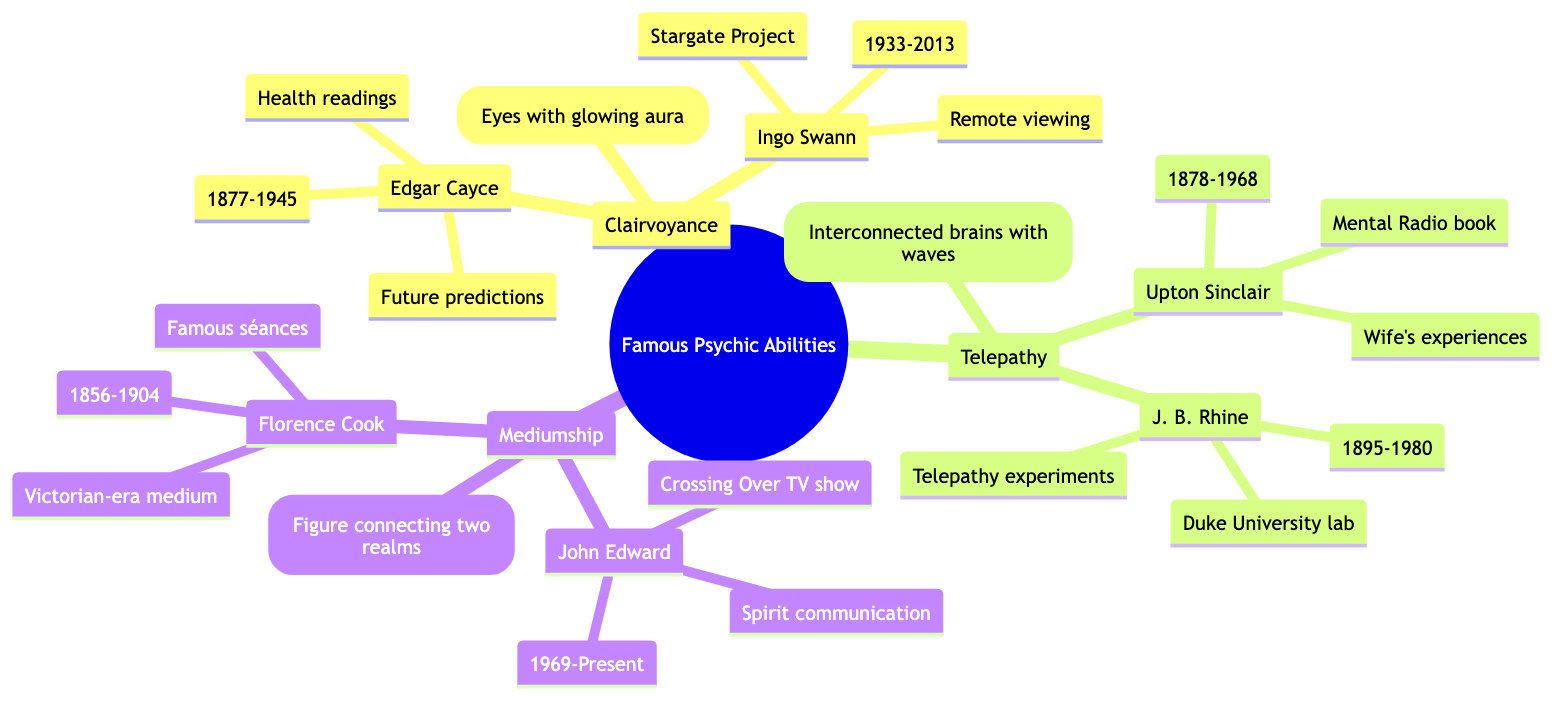What psychic ability is associated with Edgar Cayce? According to the diagram, Edgar Cayce is listed under the Clairvoyance section, which indicates that he is associated with this psychic ability.
Answer: Clairvoyance How many notable practitioners are listed for Mediumship? The Mediumship section of the diagram contains two notable practitioners: John Edward and Florence Cook. Therefore, the number is 2.
Answer: 2 What is the time frame of Ingo Swann's life as represented in the diagram? The diagram notes that Ingo Swann was born in 1933 and died in 2013. To find the time frame, you can simply observe the birth and death years provided in the node.
Answer: 1933-2013 Which practitioner is associated with telepathy experiments at Duke University? The diagram identifies J. B. Rhine as the practitioner associated with telepathy experiments conducted at Duke University, as stated in his profile.
Answer: J. B. Rhine What visual representation is associated with telepathy in the diagram? In the Telepathy section of the diagram, the visual representation is described as "Interconnected brains with waves." This indicates the symbolic illustration representing telepathy.
Answer: Interconnected brains with waves How did Florence Cook gain fame according to the diagram? The diagram specifies that Florence Cook gained fame through her Victorian-era séances, highlighting her notoriety in mediumship practices.
Answer: Famous séances What is the primary focus of Edgar Cayce's abilities? The diagram mentions that Edgar Cayce's primary focus includes health readings and future predictions, which covers the essence of his clairvoyant abilities.
Answer: Health readings How is the relationship between mediumship and spirit communication represented in the diagram? The diagram shows that mediumship is directly linked to spirit communication through the profile of John Edward, who is noted for his work in this area, thereby illustrating the connection between these two concepts.
Answer: Spirit communication What year did Upton Sinclair publish "Mental Radio"? The diagram indicates that Upton Sinclair lived from 1878 to 1968 and is linked to the publication of "Mental Radio." While the year of publication is not specified in the diagram, knowing he lived within that timeframe leads to inferring it was published during his lifetime.
Answer: Not specified 